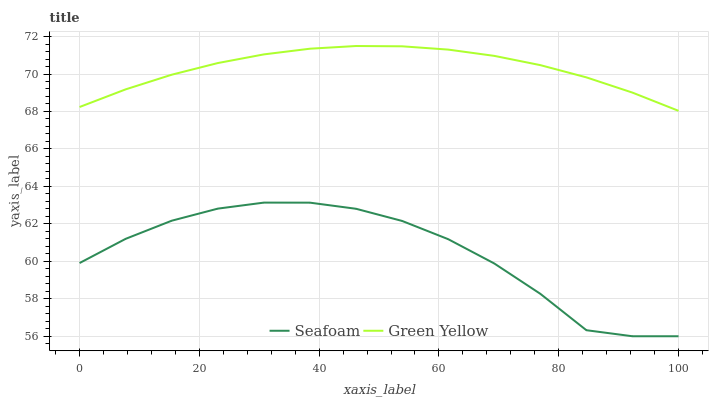Does Seafoam have the minimum area under the curve?
Answer yes or no. Yes. Does Green Yellow have the maximum area under the curve?
Answer yes or no. Yes. Does Seafoam have the maximum area under the curve?
Answer yes or no. No. Is Green Yellow the smoothest?
Answer yes or no. Yes. Is Seafoam the roughest?
Answer yes or no. Yes. Is Seafoam the smoothest?
Answer yes or no. No. Does Seafoam have the lowest value?
Answer yes or no. Yes. Does Green Yellow have the highest value?
Answer yes or no. Yes. Does Seafoam have the highest value?
Answer yes or no. No. Is Seafoam less than Green Yellow?
Answer yes or no. Yes. Is Green Yellow greater than Seafoam?
Answer yes or no. Yes. Does Seafoam intersect Green Yellow?
Answer yes or no. No. 